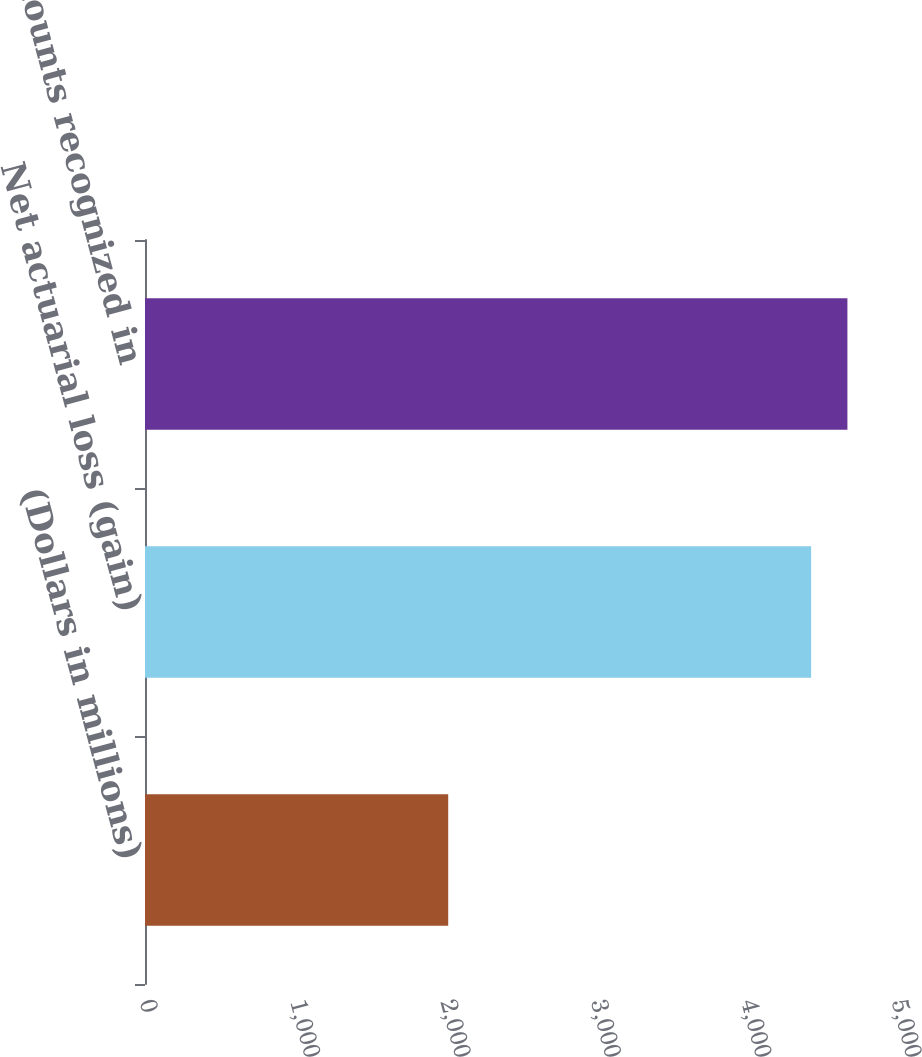Convert chart. <chart><loc_0><loc_0><loc_500><loc_500><bar_chart><fcel>(Dollars in millions)<fcel>Net actuarial loss (gain)<fcel>Amounts recognized in<nl><fcel>2016<fcel>4429<fcel>4670.3<nl></chart> 